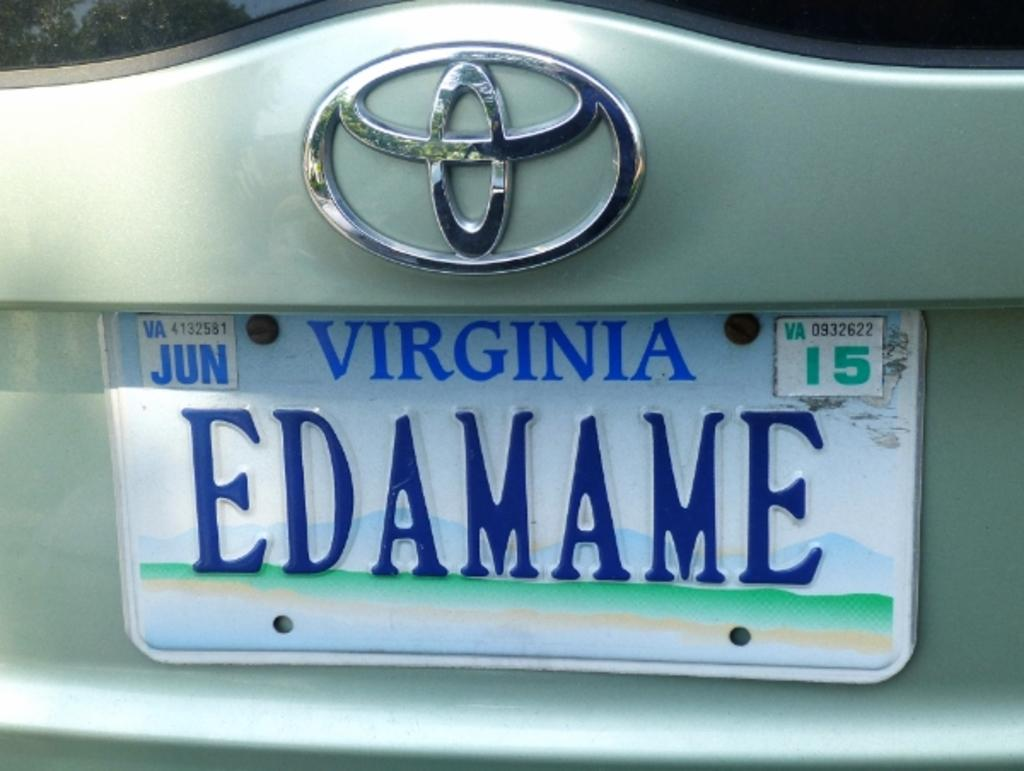<image>
Give a short and clear explanation of the subsequent image. A white and blue Virginia license plate is labeled EDAMAME. 